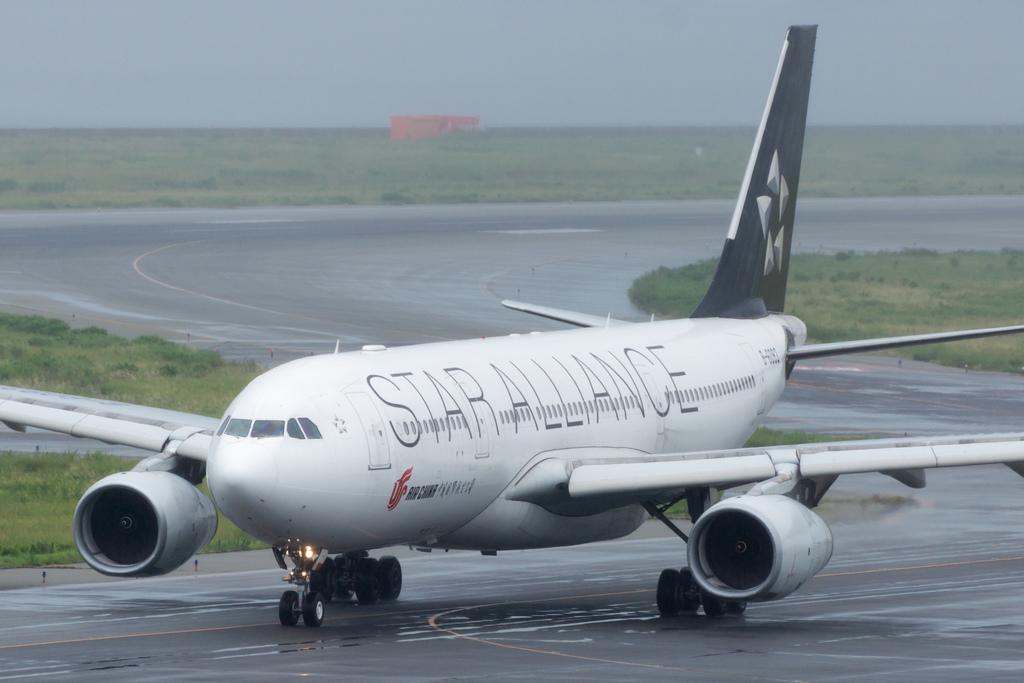<image>
Summarize the visual content of the image. A white airplane is on the runway and on the side it says STAR ALLIANCE. 